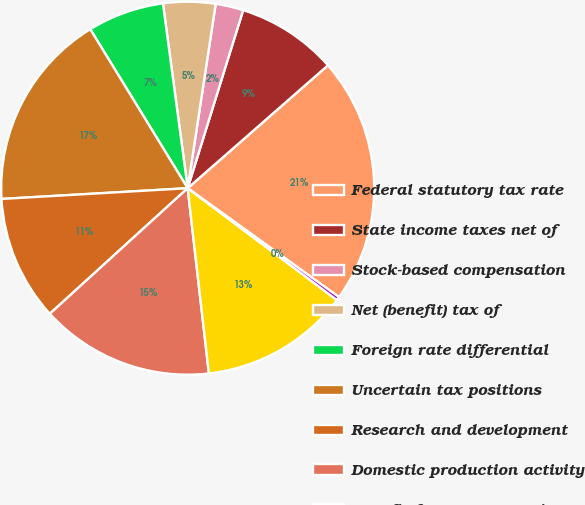Convert chart to OTSL. <chart><loc_0><loc_0><loc_500><loc_500><pie_chart><fcel>Federal statutory tax rate<fcel>State income taxes net of<fcel>Stock-based compensation<fcel>Net (benefit) tax of<fcel>Foreign rate differential<fcel>Uncertain tax positions<fcel>Research and development<fcel>Domestic production activity<fcel>Benefit from restructuring<fcel>Other<nl><fcel>21.38%<fcel>8.74%<fcel>2.41%<fcel>4.52%<fcel>6.63%<fcel>17.17%<fcel>10.84%<fcel>15.06%<fcel>12.95%<fcel>0.31%<nl></chart> 